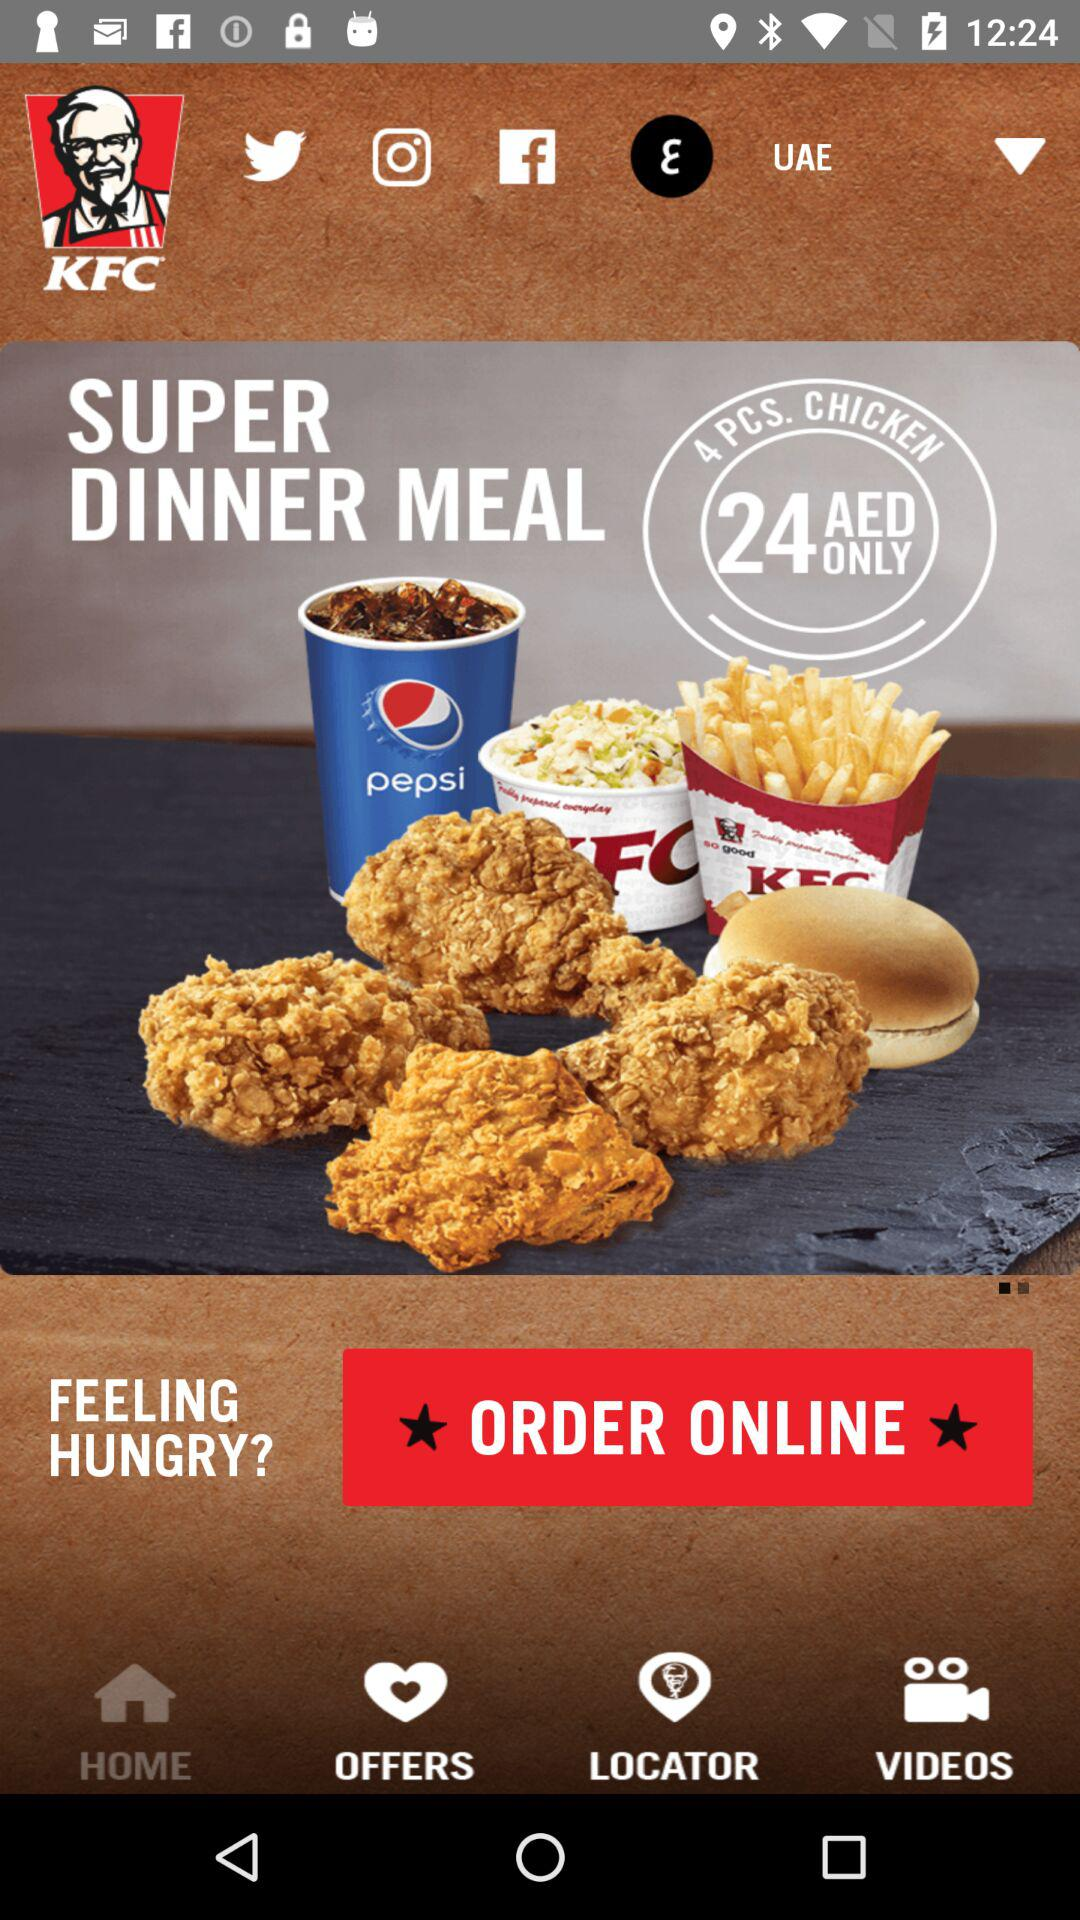Which is the current location? The current location is the UAE. 